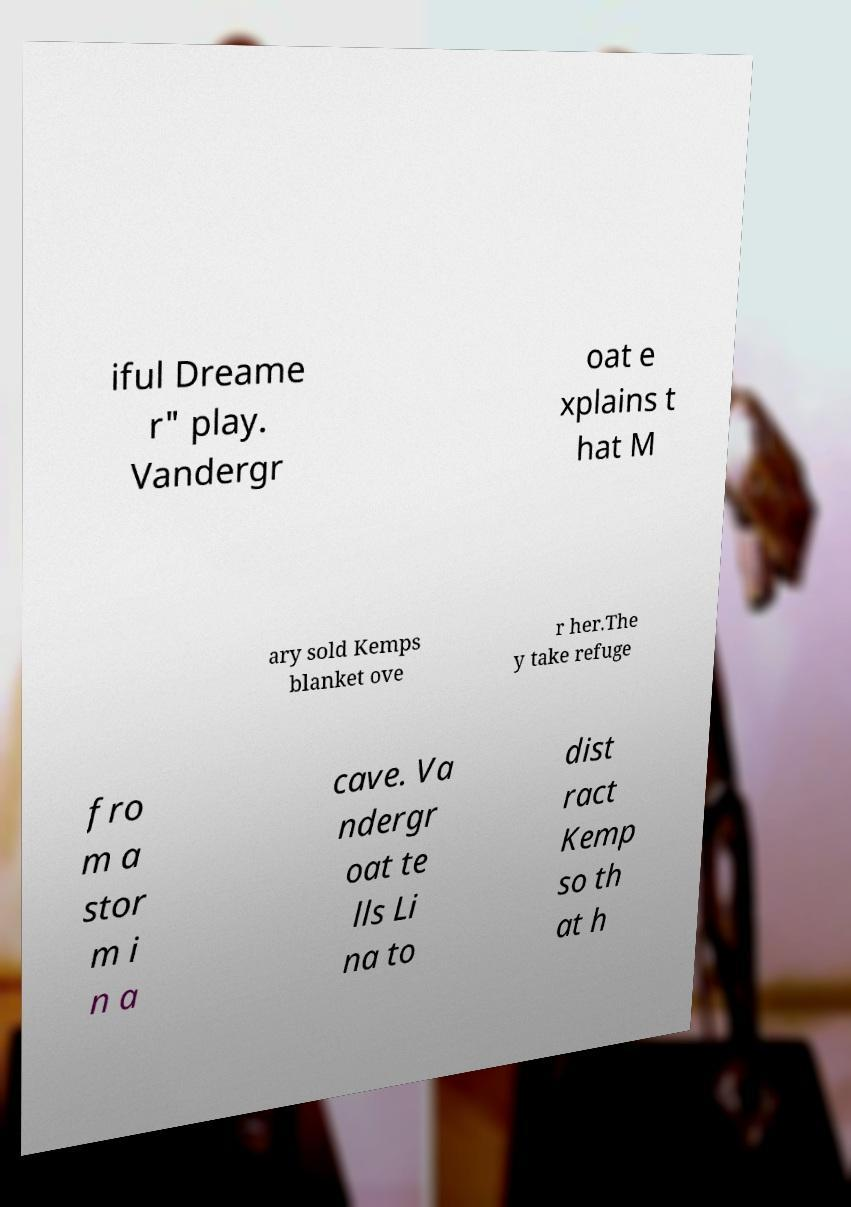I need the written content from this picture converted into text. Can you do that? iful Dreame r" play. Vandergr oat e xplains t hat M ary sold Kemps blanket ove r her.The y take refuge fro m a stor m i n a cave. Va ndergr oat te lls Li na to dist ract Kemp so th at h 